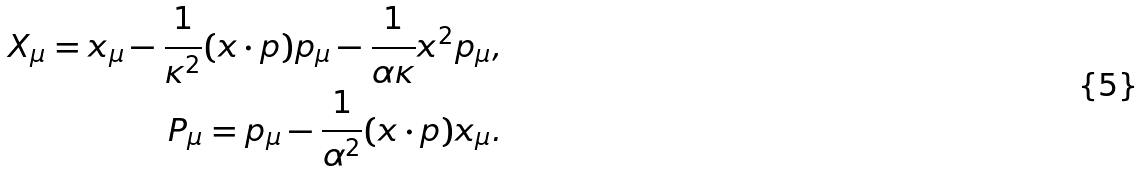Convert formula to latex. <formula><loc_0><loc_0><loc_500><loc_500>X _ { \mu } = x _ { \mu } - \frac { 1 } { \kappa ^ { 2 } } ( x \cdot p ) p _ { \mu } - \frac { 1 } { \alpha \kappa } x ^ { 2 } p _ { \mu } , \\ P _ { \mu } = p _ { \mu } - \frac { 1 } { \alpha ^ { 2 } } ( x \cdot p ) x _ { \mu } .</formula> 